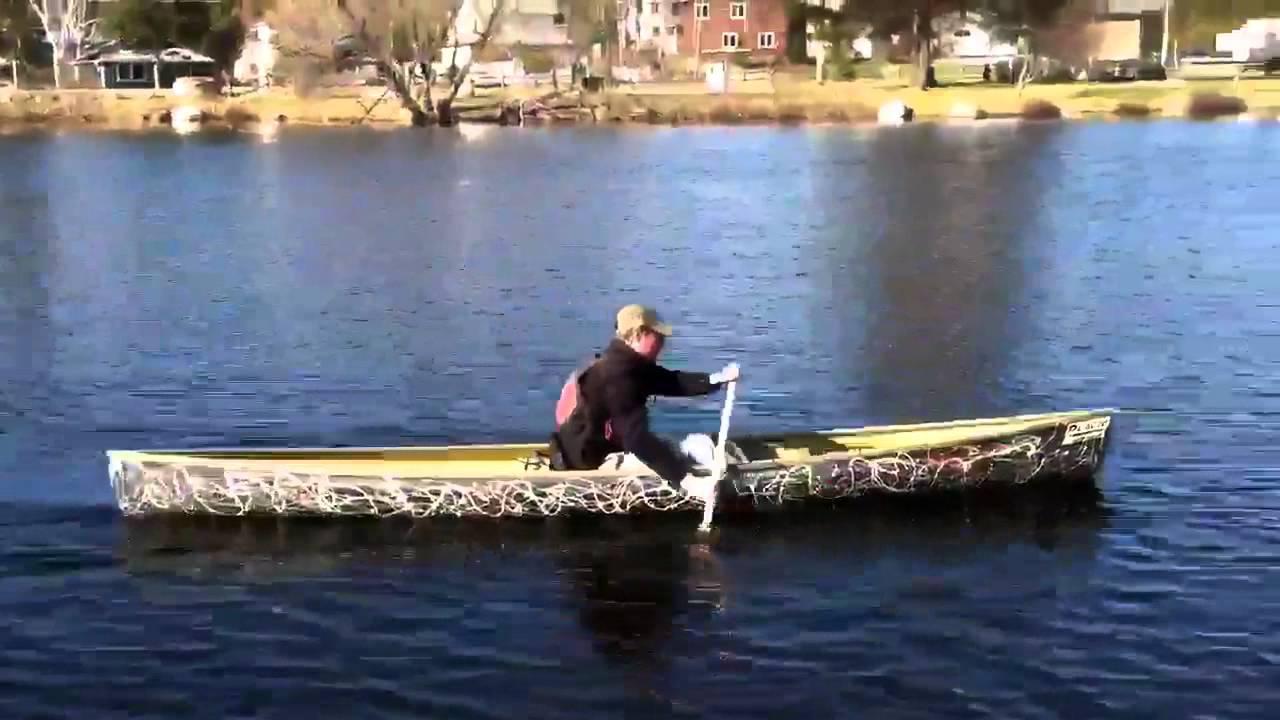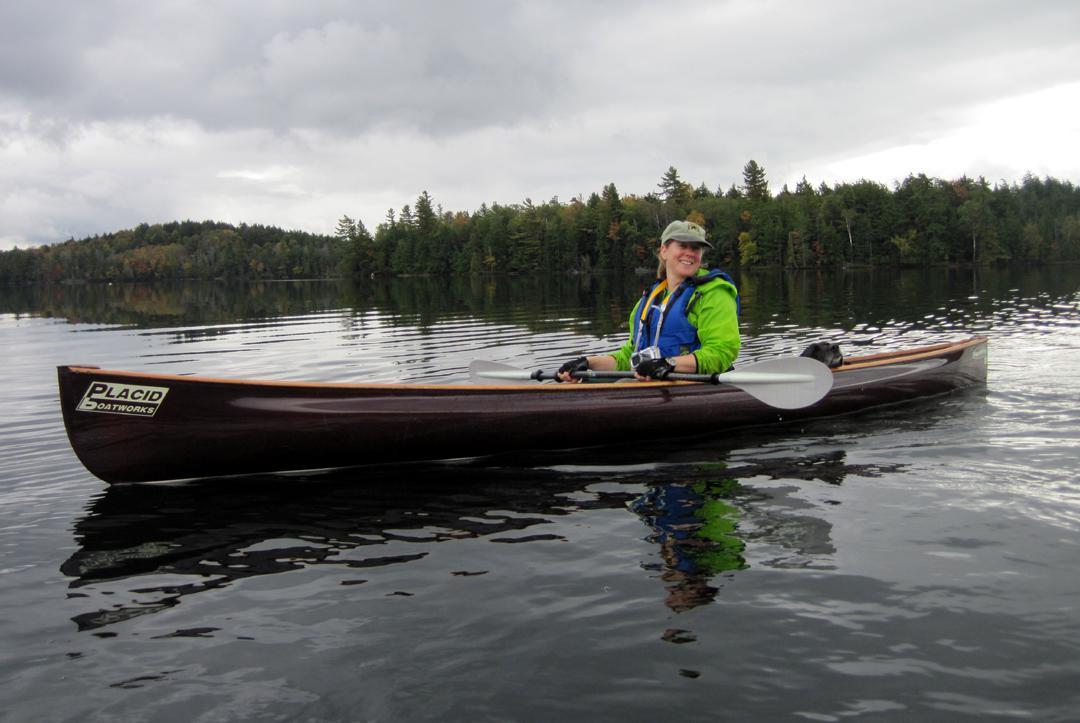The first image is the image on the left, the second image is the image on the right. Considering the images on both sides, is "There is exactly one canoe without anyone in it." valid? Answer yes or no. No. The first image is the image on the left, the second image is the image on the right. For the images shown, is this caption "One image shows multiple canoes with rowers in them heading leftward, and the other image features a single riderless canoe containing fishing poles floating on the water." true? Answer yes or no. No. 